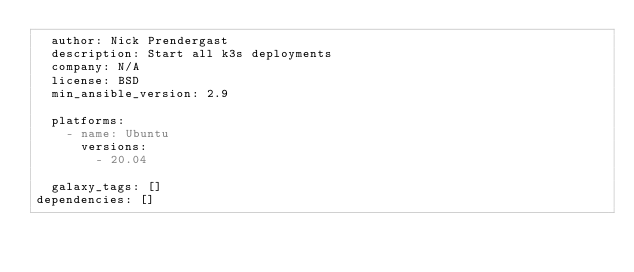<code> <loc_0><loc_0><loc_500><loc_500><_YAML_>  author: Nick Prendergast
  description: Start all k3s deployments
  company: N/A
  license: BSD
  min_ansible_version: 2.9

  platforms:
    - name: Ubuntu
      versions:
        - 20.04

  galaxy_tags: []
dependencies: []
</code> 